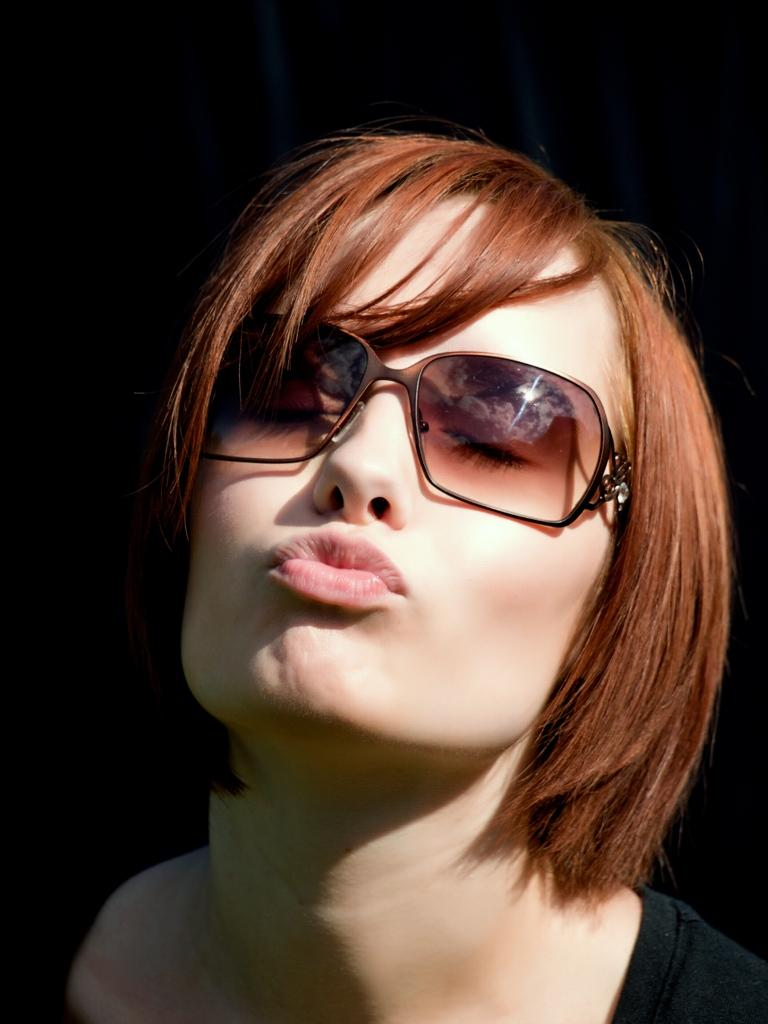Who is present in the image? There is a woman in the image. What is the woman wearing on her face? The woman is wearing goggles. What can be observed about the background of the image? The background of the image is dark. What type of ship can be seen in the background of the image? There is no ship present in the image; the background is dark. How many dolls are visible on the woman's head in the image? There are no dolls present in the image; the woman is wearing goggles. 